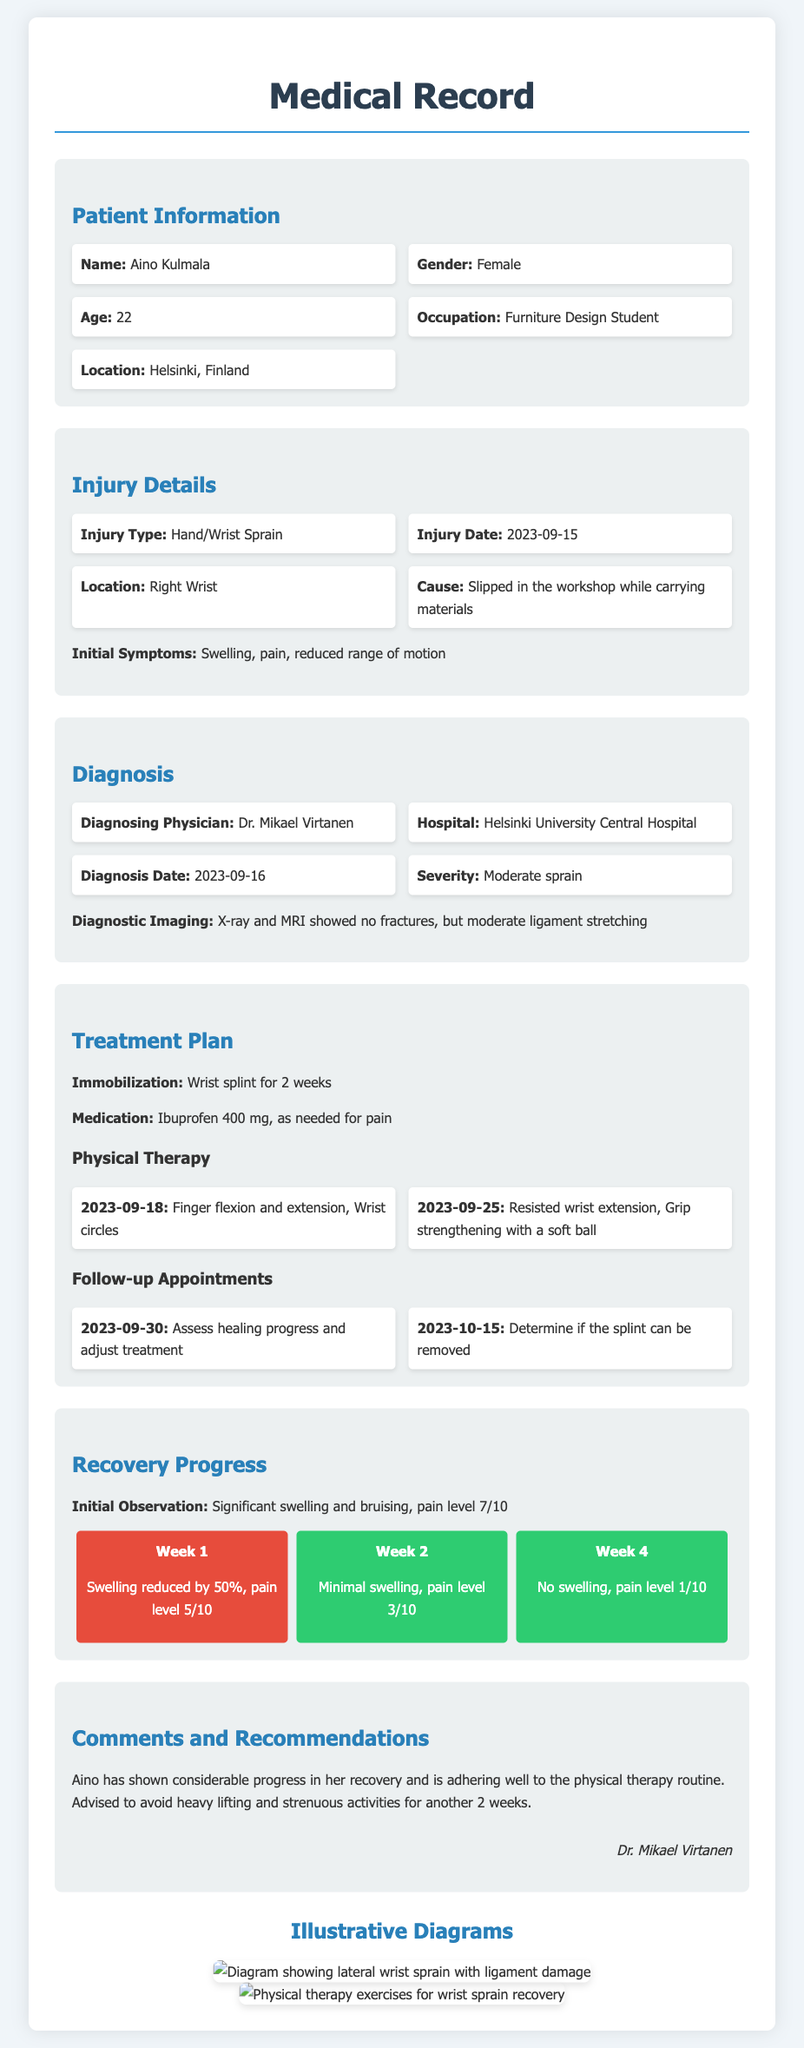What is the patient's name? The patient's name is clearly stated at the beginning of the document under Patient Information.
Answer: Aino Kulmala What type of injury did Aino sustain? The type of injury is specified in the Injury Details section of the document.
Answer: Hand/Wrist Sprain When did the injury occur? The date of the injury is noted in the Injury Details section.
Answer: 2023-09-15 What was recommended for immobilization? The treatment plan section mentions what was used for immobilization.
Answer: Wrist splint for 2 weeks Who was the diagnosing physician? The diagnosing physician's name is provided in the Diagnosis section of the document.
Answer: Dr. Mikael Virtanen What level was Aino's pain in Week 1? The progress section outlines the pain levels at different stages of recovery.
Answer: 5/10 How much did swelling reduce by Week 1? The recovery progress details the specific reduction in swelling after the first week.
Answer: 50% What is the follow-up appointment date to assess healing? The follow-up appointment date is listed in the Treatment Plan section for assessing healing progress.
Answer: 2023-09-30 What is the recommendation regarding heavy lifting? The comments and recommendations section provides guidance on activities that should be avoided.
Answer: Avoid heavy lifting and strenuous activities 